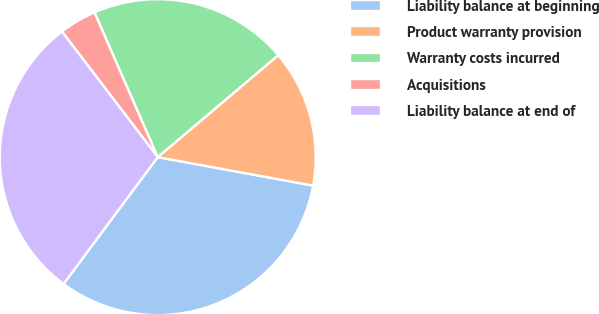Convert chart to OTSL. <chart><loc_0><loc_0><loc_500><loc_500><pie_chart><fcel>Liability balance at beginning<fcel>Product warranty provision<fcel>Warranty costs incurred<fcel>Acquisitions<fcel>Liability balance at end of<nl><fcel>32.28%<fcel>14.06%<fcel>20.38%<fcel>3.81%<fcel>29.46%<nl></chart> 